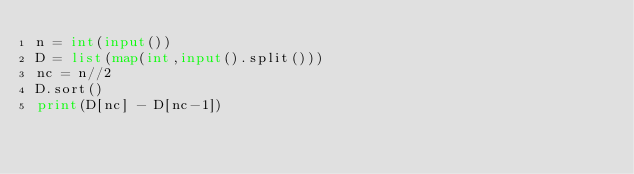Convert code to text. <code><loc_0><loc_0><loc_500><loc_500><_Python_>n = int(input())
D = list(map(int,input().split()))
nc = n//2
D.sort()
print(D[nc] - D[nc-1])</code> 